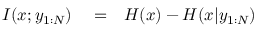Convert formula to latex. <formula><loc_0><loc_0><loc_500><loc_500>\begin{array} { r l r } { I ( x ; y _ { 1 \colon N } ) } & = } & { H ( x ) - H ( x | y _ { 1 \colon N } ) } \end{array}</formula> 